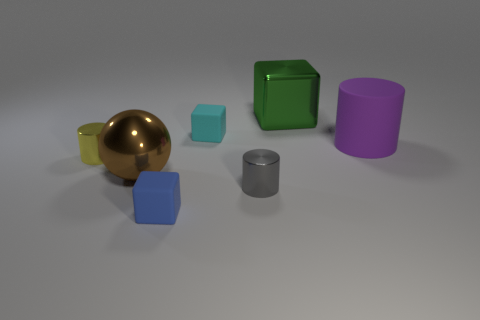Subtract all cyan cubes. How many cubes are left? 2 Subtract all yellow cylinders. How many cylinders are left? 2 Subtract 2 blocks. How many blocks are left? 1 Add 2 tiny gray shiny things. How many objects exist? 9 Subtract all spheres. How many objects are left? 6 Subtract 1 cyan cubes. How many objects are left? 6 Subtract all red cubes. Subtract all green balls. How many cubes are left? 3 Subtract all green balls. How many yellow cylinders are left? 1 Subtract all brown balls. Subtract all yellow objects. How many objects are left? 5 Add 6 large rubber things. How many large rubber things are left? 7 